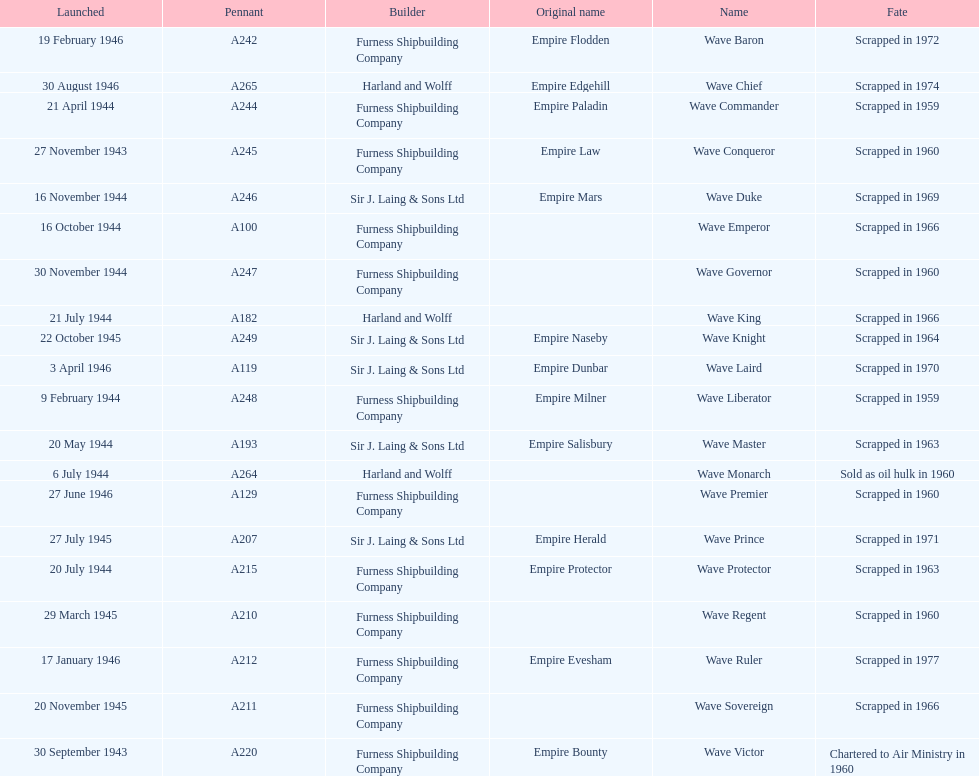Which other ship was launched in the same year as the wave victor? Wave Conqueror. 